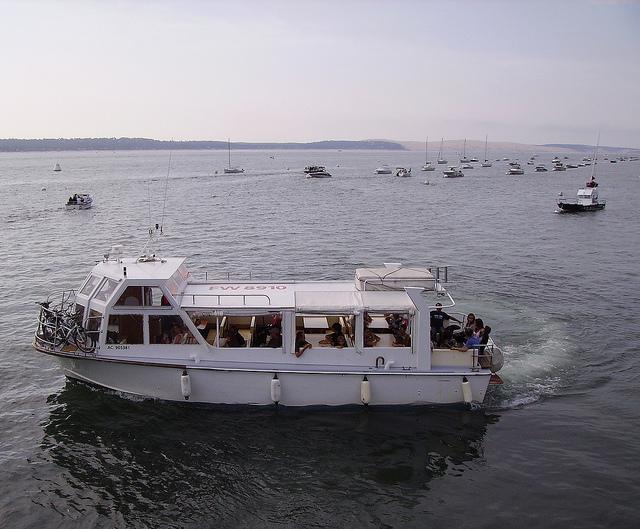Is this a civilian boat?
Concise answer only. Yes. Are there any people on the boats?
Give a very brief answer. Yes. What color is the boat at the forefront of the picture?
Concise answer only. White. How many boats are there?
Answer briefly. 20. Is there a man walking in the background?
Short answer required. No. Is the sun showing in this picture?
Answer briefly. No. 